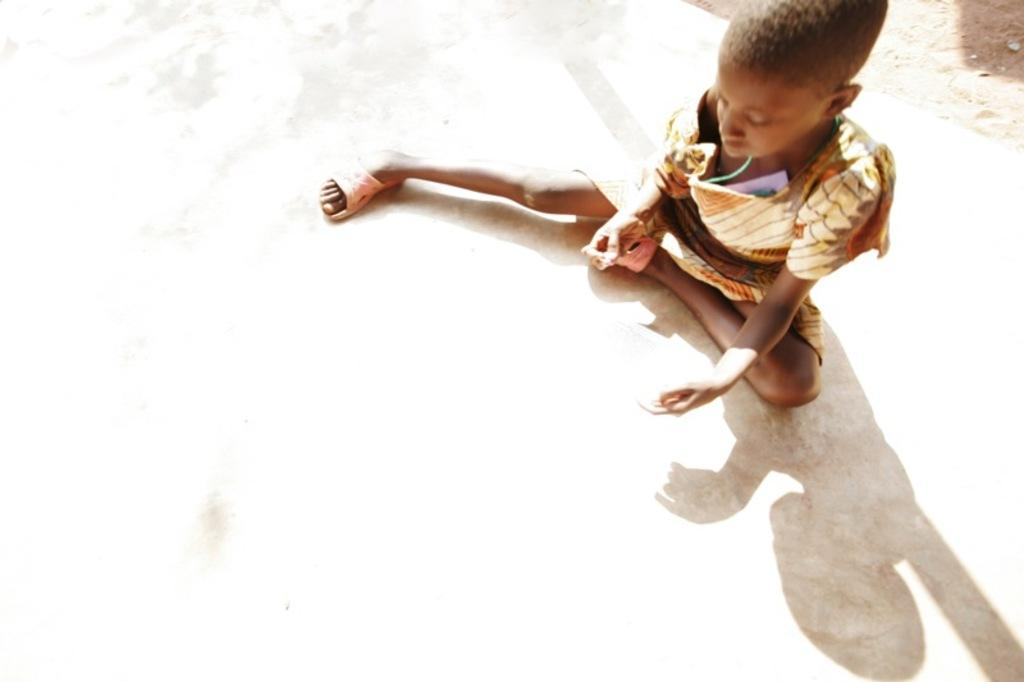What is the main subject of the image? The main subject of the image is a kid. What is the kid doing in the image? The kid is sitting on the floor. What else can be observed about the kid in the image? The shadow of the kid is visible in the image. How is the shadow of the kid interacting with the environment in the image? The shadow is reflecting on the floor. What type of cheese can be seen in the image? There is no cheese present in the image. Can you describe the bee buzzing around the kid in the image? There is no bee present in the image; the focus is on the kid and their shadow. 